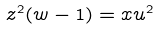<formula> <loc_0><loc_0><loc_500><loc_500>z ^ { 2 } ( w - 1 ) = x u ^ { 2 }</formula> 